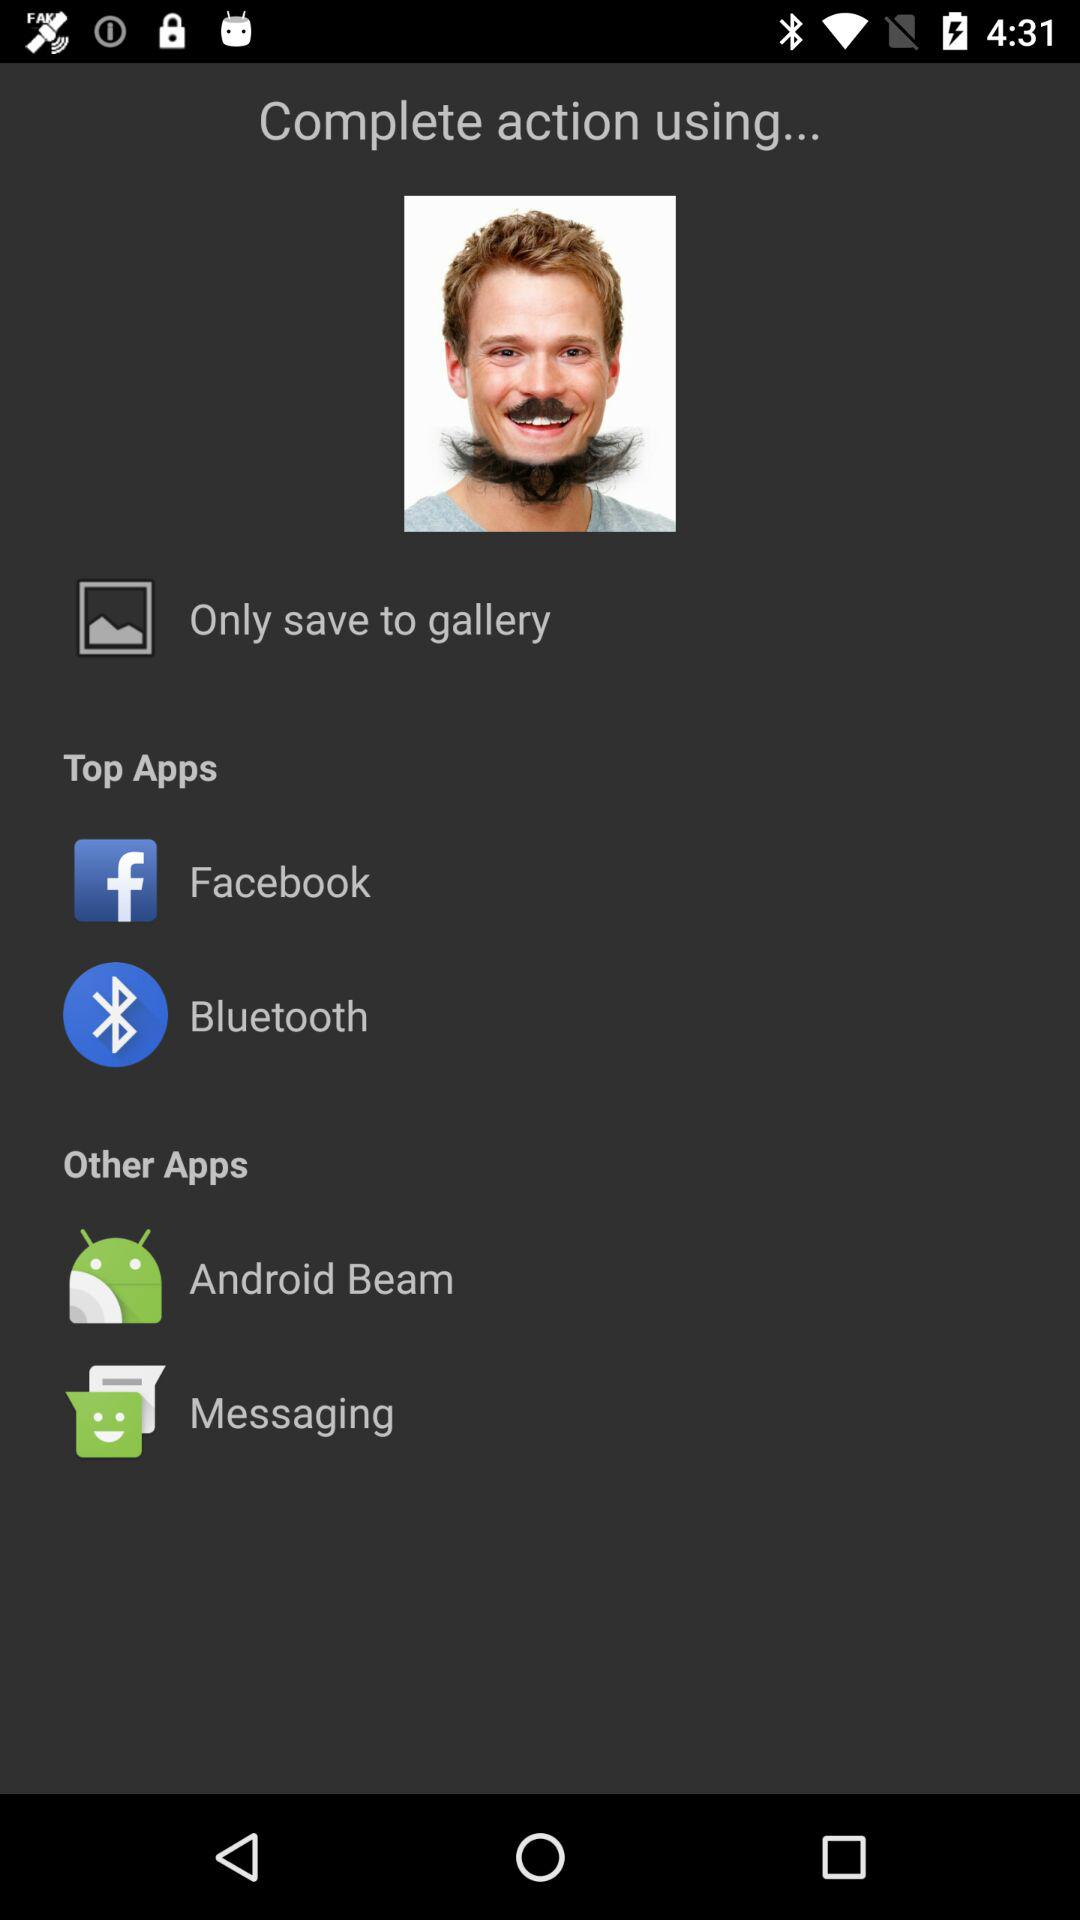Through which app can you share? You can share through "Facebook", "Bluetooth", "Android Beam" and "Messaging". 